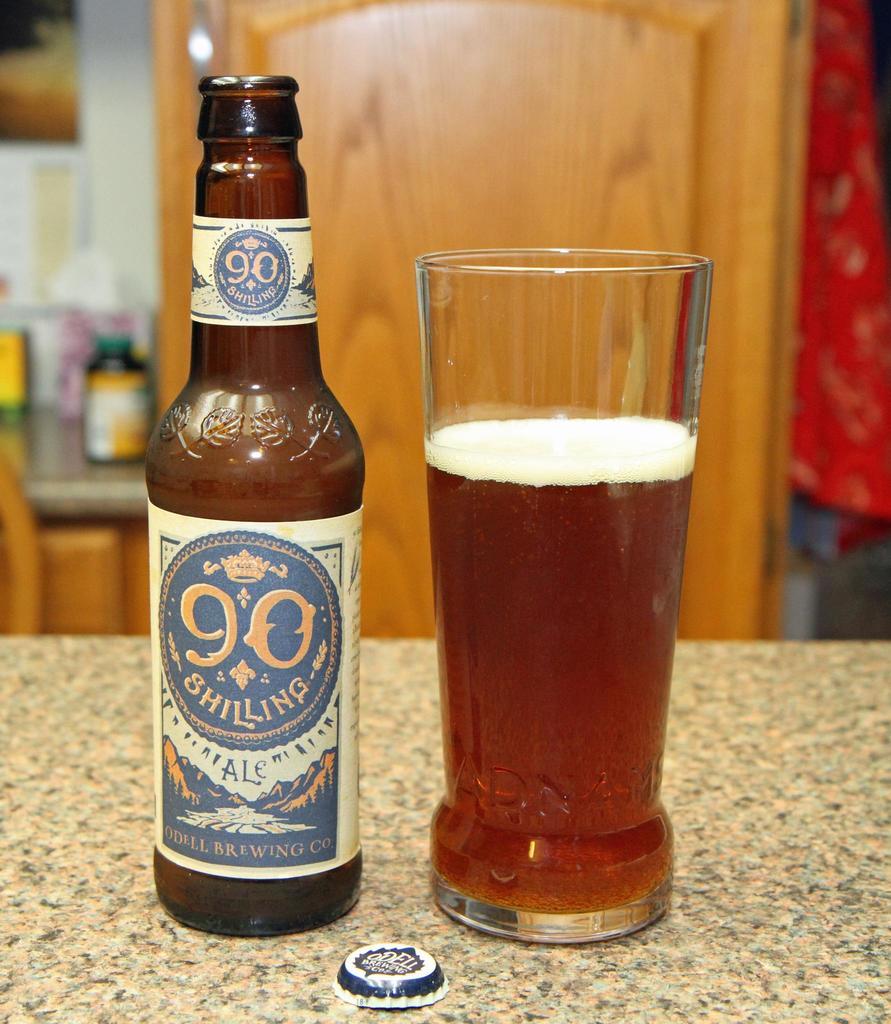What type of old money is this beer named after?
Give a very brief answer. Shilling. What is the type of beer?
Provide a succinct answer. Ale. 